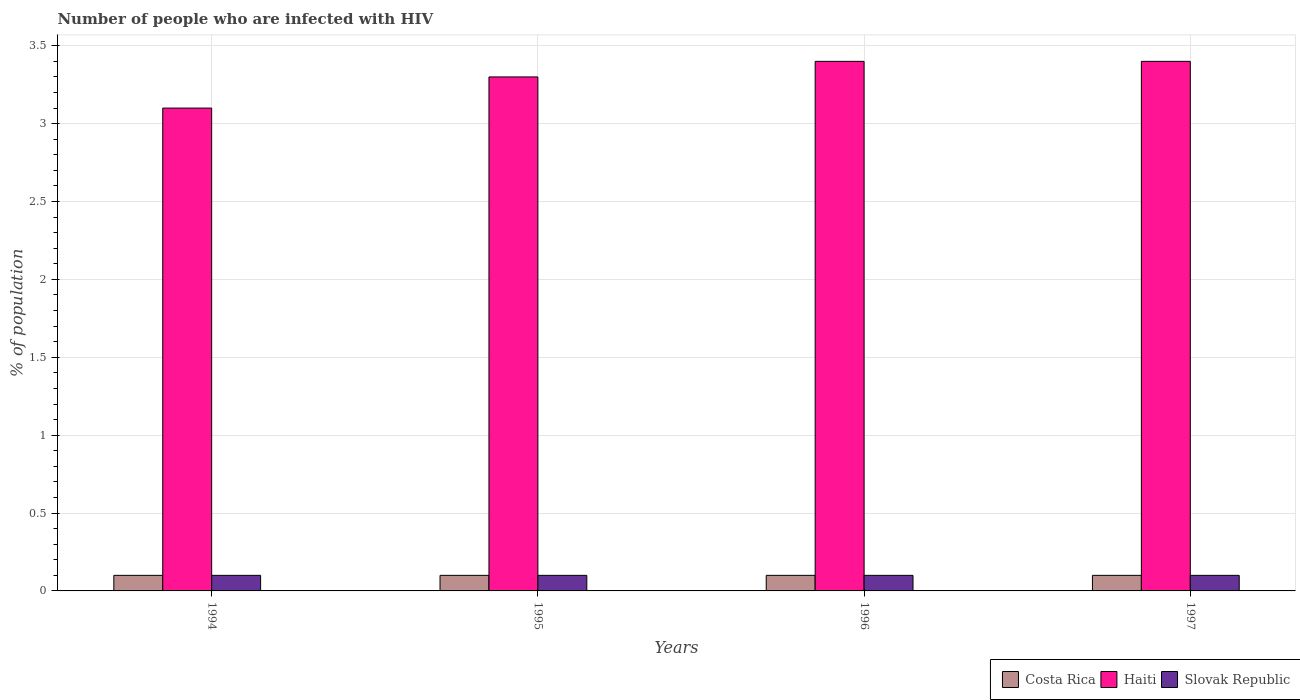How many different coloured bars are there?
Offer a terse response. 3. Are the number of bars per tick equal to the number of legend labels?
Offer a very short reply. Yes. How many bars are there on the 1st tick from the left?
Ensure brevity in your answer.  3. Across all years, what is the minimum percentage of HIV infected population in in Costa Rica?
Keep it short and to the point. 0.1. In which year was the percentage of HIV infected population in in Costa Rica maximum?
Provide a succinct answer. 1994. In which year was the percentage of HIV infected population in in Slovak Republic minimum?
Your response must be concise. 1994. What is the difference between the percentage of HIV infected population in in Haiti in 1995 and that in 1996?
Your response must be concise. -0.1. What is the difference between the percentage of HIV infected population in in Slovak Republic in 1996 and the percentage of HIV infected population in in Costa Rica in 1994?
Your answer should be compact. 0. What is the average percentage of HIV infected population in in Slovak Republic per year?
Your response must be concise. 0.1. In how many years, is the percentage of HIV infected population in in Slovak Republic greater than 0.8 %?
Provide a succinct answer. 0. What is the difference between the highest and the second highest percentage of HIV infected population in in Haiti?
Provide a succinct answer. 0. What is the difference between the highest and the lowest percentage of HIV infected population in in Haiti?
Offer a very short reply. 0.3. In how many years, is the percentage of HIV infected population in in Costa Rica greater than the average percentage of HIV infected population in in Costa Rica taken over all years?
Offer a very short reply. 0. What does the 2nd bar from the left in 1997 represents?
Your answer should be compact. Haiti. What does the 2nd bar from the right in 1996 represents?
Provide a short and direct response. Haiti. How many bars are there?
Ensure brevity in your answer.  12. Are all the bars in the graph horizontal?
Give a very brief answer. No. Does the graph contain grids?
Offer a very short reply. Yes. Where does the legend appear in the graph?
Give a very brief answer. Bottom right. How are the legend labels stacked?
Keep it short and to the point. Horizontal. What is the title of the graph?
Give a very brief answer. Number of people who are infected with HIV. Does "Upper middle income" appear as one of the legend labels in the graph?
Your response must be concise. No. What is the label or title of the Y-axis?
Keep it short and to the point. % of population. What is the % of population of Costa Rica in 1994?
Your answer should be compact. 0.1. What is the % of population of Haiti in 1994?
Make the answer very short. 3.1. What is the % of population in Costa Rica in 1995?
Your answer should be compact. 0.1. What is the % of population in Haiti in 1995?
Give a very brief answer. 3.3. What is the % of population of Costa Rica in 1996?
Ensure brevity in your answer.  0.1. What is the % of population in Haiti in 1996?
Provide a short and direct response. 3.4. What is the % of population in Haiti in 1997?
Provide a short and direct response. 3.4. Across all years, what is the maximum % of population of Costa Rica?
Offer a terse response. 0.1. Across all years, what is the maximum % of population in Haiti?
Make the answer very short. 3.4. Across all years, what is the maximum % of population of Slovak Republic?
Keep it short and to the point. 0.1. Across all years, what is the minimum % of population in Slovak Republic?
Keep it short and to the point. 0.1. What is the total % of population in Costa Rica in the graph?
Your answer should be compact. 0.4. What is the total % of population in Haiti in the graph?
Keep it short and to the point. 13.2. What is the difference between the % of population of Haiti in 1994 and that in 1995?
Ensure brevity in your answer.  -0.2. What is the difference between the % of population of Costa Rica in 1994 and that in 1996?
Provide a succinct answer. 0. What is the difference between the % of population in Slovak Republic in 1994 and that in 1996?
Offer a terse response. 0. What is the difference between the % of population in Haiti in 1994 and that in 1997?
Provide a short and direct response. -0.3. What is the difference between the % of population of Haiti in 1995 and that in 1997?
Ensure brevity in your answer.  -0.1. What is the difference between the % of population of Slovak Republic in 1995 and that in 1997?
Ensure brevity in your answer.  0. What is the difference between the % of population of Costa Rica in 1996 and that in 1997?
Provide a succinct answer. 0. What is the difference between the % of population in Haiti in 1996 and that in 1997?
Provide a short and direct response. 0. What is the difference between the % of population in Slovak Republic in 1996 and that in 1997?
Offer a terse response. 0. What is the difference between the % of population of Costa Rica in 1994 and the % of population of Haiti in 1996?
Ensure brevity in your answer.  -3.3. What is the difference between the % of population in Haiti in 1994 and the % of population in Slovak Republic in 1996?
Ensure brevity in your answer.  3. What is the difference between the % of population in Costa Rica in 1994 and the % of population in Slovak Republic in 1997?
Your response must be concise. 0. What is the difference between the % of population in Haiti in 1994 and the % of population in Slovak Republic in 1997?
Provide a short and direct response. 3. What is the difference between the % of population in Haiti in 1995 and the % of population in Slovak Republic in 1996?
Provide a succinct answer. 3.2. What is the difference between the % of population in Costa Rica in 1995 and the % of population in Slovak Republic in 1997?
Give a very brief answer. 0. What is the difference between the % of population of Costa Rica in 1996 and the % of population of Haiti in 1997?
Your answer should be very brief. -3.3. What is the difference between the % of population of Haiti in 1996 and the % of population of Slovak Republic in 1997?
Make the answer very short. 3.3. What is the average % of population of Costa Rica per year?
Ensure brevity in your answer.  0.1. What is the average % of population of Haiti per year?
Give a very brief answer. 3.3. What is the average % of population of Slovak Republic per year?
Offer a very short reply. 0.1. In the year 1994, what is the difference between the % of population in Costa Rica and % of population in Haiti?
Offer a very short reply. -3. In the year 1994, what is the difference between the % of population in Costa Rica and % of population in Slovak Republic?
Your answer should be compact. 0. In the year 1995, what is the difference between the % of population in Haiti and % of population in Slovak Republic?
Give a very brief answer. 3.2. In the year 1996, what is the difference between the % of population of Costa Rica and % of population of Slovak Republic?
Provide a short and direct response. 0. In the year 1996, what is the difference between the % of population of Haiti and % of population of Slovak Republic?
Offer a terse response. 3.3. In the year 1997, what is the difference between the % of population of Costa Rica and % of population of Haiti?
Keep it short and to the point. -3.3. What is the ratio of the % of population in Haiti in 1994 to that in 1995?
Your response must be concise. 0.94. What is the ratio of the % of population in Slovak Republic in 1994 to that in 1995?
Give a very brief answer. 1. What is the ratio of the % of population of Haiti in 1994 to that in 1996?
Keep it short and to the point. 0.91. What is the ratio of the % of population of Costa Rica in 1994 to that in 1997?
Ensure brevity in your answer.  1. What is the ratio of the % of population in Haiti in 1994 to that in 1997?
Offer a very short reply. 0.91. What is the ratio of the % of population in Slovak Republic in 1994 to that in 1997?
Your answer should be compact. 1. What is the ratio of the % of population of Haiti in 1995 to that in 1996?
Make the answer very short. 0.97. What is the ratio of the % of population in Costa Rica in 1995 to that in 1997?
Make the answer very short. 1. What is the ratio of the % of population in Haiti in 1995 to that in 1997?
Your answer should be very brief. 0.97. What is the ratio of the % of population in Slovak Republic in 1995 to that in 1997?
Your answer should be very brief. 1. What is the ratio of the % of population of Costa Rica in 1996 to that in 1997?
Keep it short and to the point. 1. What is the ratio of the % of population in Slovak Republic in 1996 to that in 1997?
Provide a succinct answer. 1. What is the difference between the highest and the second highest % of population of Haiti?
Provide a succinct answer. 0. What is the difference between the highest and the second highest % of population of Slovak Republic?
Keep it short and to the point. 0. What is the difference between the highest and the lowest % of population in Costa Rica?
Make the answer very short. 0. What is the difference between the highest and the lowest % of population of Slovak Republic?
Offer a very short reply. 0. 